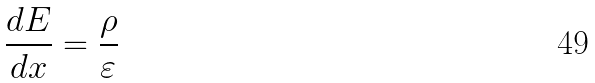Convert formula to latex. <formula><loc_0><loc_0><loc_500><loc_500>\frac { d E } { d x } = \frac { \rho } { \varepsilon }</formula> 